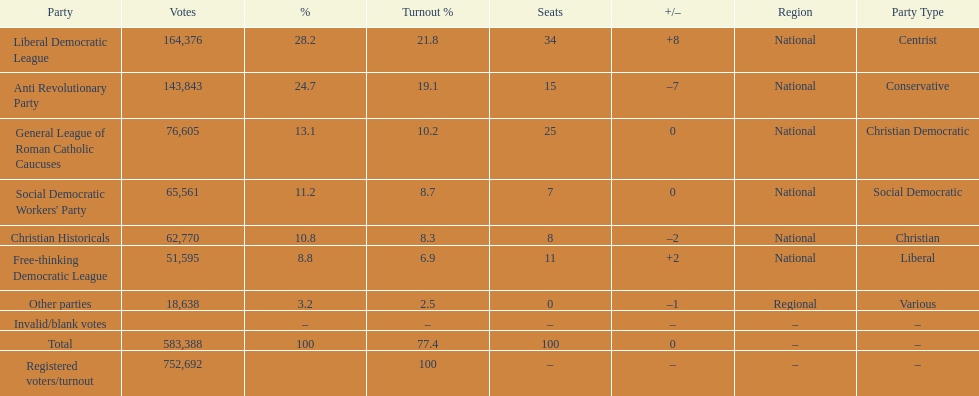How many more votes did the liberal democratic league win over the free-thinking democratic league? 112,781. 